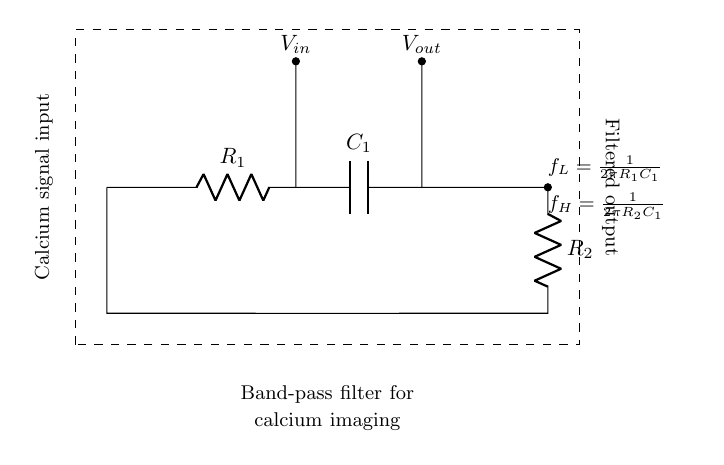What is the function of this circuit? The circuit is a band-pass filter, which allows signals within a certain frequency range to pass while attenuating frequencies outside that range. This is evident from the labeling on the circuit diagram that states its purpose.
Answer: band-pass filter What components are used in this circuit? The circuit consists of two resistors and one capacitor, which are labeled as R1, R2, and C1 respectively. These components are commonly used in filter applications to determine the frequency response of the circuit.
Answer: Resistors and capacitor What type of filter is implemented here? The circuit implements a band-pass filter, as indicated in the description and shown by the configuration of the components that define a specific frequency range.
Answer: band-pass filter What is the lower cutoff frequency equation? The lower cutoff frequency is calculated using the equation f_L = 1/(2πR1C1). This is derived from the characteristics of the resistors and capacitor in the circuit.
Answer: 1/(2πR1C1) What does the node labeled Vout represent? The node labeled Vout indicates the output voltage of the filter, which is taken from the junction of R2 and C1, representing the filtered signal after passing through the band-pass filter.
Answer: filtered output How does the circuit isolate specific frequencies? The circuit uses R1 and R2 along with C1 to create a response that allows certain frequencies to pass while blocking others. The values of these components set the frequency range at which the filter operates effectively.
Answer: through component values What role does capacitor C1 play in the circuit? Capacitor C1 is crucial in determining the frequency response of the filter, as it works in combination with the resistors to establish both the lower and upper cutoff frequencies. This interactivity defines the band of frequencies that will be passed through.
Answer: frequency response 